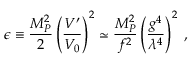<formula> <loc_0><loc_0><loc_500><loc_500>\epsilon \equiv \frac { M _ { P } ^ { 2 } } { 2 } \left ( \frac { V ^ { \prime } } { V _ { 0 } } \right ) ^ { 2 } \simeq \frac { M _ { P } ^ { 2 } } { f ^ { 2 } } \left ( \frac { g ^ { 4 } } { \lambda ^ { 4 } } \right ) ^ { 2 } \, ,</formula> 